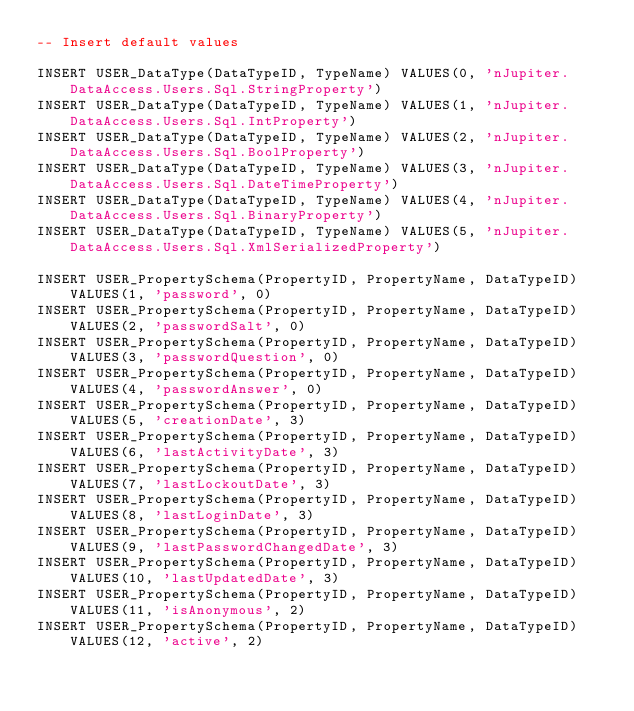Convert code to text. <code><loc_0><loc_0><loc_500><loc_500><_SQL_>-- Insert default values

INSERT USER_DataType(DataTypeID, TypeName) VALUES(0, 'nJupiter.DataAccess.Users.Sql.StringProperty')
INSERT USER_DataType(DataTypeID, TypeName) VALUES(1, 'nJupiter.DataAccess.Users.Sql.IntProperty')
INSERT USER_DataType(DataTypeID, TypeName) VALUES(2, 'nJupiter.DataAccess.Users.Sql.BoolProperty')
INSERT USER_DataType(DataTypeID, TypeName) VALUES(3, 'nJupiter.DataAccess.Users.Sql.DateTimeProperty')
INSERT USER_DataType(DataTypeID, TypeName) VALUES(4, 'nJupiter.DataAccess.Users.Sql.BinaryProperty')
INSERT USER_DataType(DataTypeID, TypeName) VALUES(5, 'nJupiter.DataAccess.Users.Sql.XmlSerializedProperty')

INSERT USER_PropertySchema(PropertyID, PropertyName, DataTypeID) VALUES(1, 'password', 0)
INSERT USER_PropertySchema(PropertyID, PropertyName, DataTypeID) VALUES(2, 'passwordSalt', 0)
INSERT USER_PropertySchema(PropertyID, PropertyName, DataTypeID) VALUES(3, 'passwordQuestion', 0)
INSERT USER_PropertySchema(PropertyID, PropertyName, DataTypeID) VALUES(4, 'passwordAnswer', 0)
INSERT USER_PropertySchema(PropertyID, PropertyName, DataTypeID) VALUES(5, 'creationDate', 3)
INSERT USER_PropertySchema(PropertyID, PropertyName, DataTypeID) VALUES(6, 'lastActivityDate', 3)
INSERT USER_PropertySchema(PropertyID, PropertyName, DataTypeID) VALUES(7, 'lastLockoutDate', 3)
INSERT USER_PropertySchema(PropertyID, PropertyName, DataTypeID) VALUES(8, 'lastLoginDate', 3)
INSERT USER_PropertySchema(PropertyID, PropertyName, DataTypeID) VALUES(9, 'lastPasswordChangedDate', 3)
INSERT USER_PropertySchema(PropertyID, PropertyName, DataTypeID) VALUES(10, 'lastUpdatedDate', 3)
INSERT USER_PropertySchema(PropertyID, PropertyName, DataTypeID) VALUES(11, 'isAnonymous', 2)
INSERT USER_PropertySchema(PropertyID, PropertyName, DataTypeID) VALUES(12, 'active', 2)</code> 